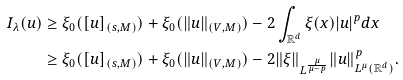<formula> <loc_0><loc_0><loc_500><loc_500>I _ { \lambda } ( u ) & \geq \xi _ { 0 } ( [ u ] _ { ( s , M ) } ) + \xi _ { 0 } ( \| u \| _ { ( V , M ) } ) - 2 \int _ { \mathbb { R } ^ { d } } \xi ( x ) | u | ^ { p } d x \\ & \geq \xi _ { 0 } ( [ u ] _ { ( s , M ) } ) + \xi _ { 0 } ( \| u \| _ { ( V , M ) } ) - 2 \| \xi \| _ { L ^ { \frac { \mu } { \mu - p } } } \| u \| _ { L ^ { \mu } ( \mathbb { R } ^ { d } ) } ^ { p } .</formula> 